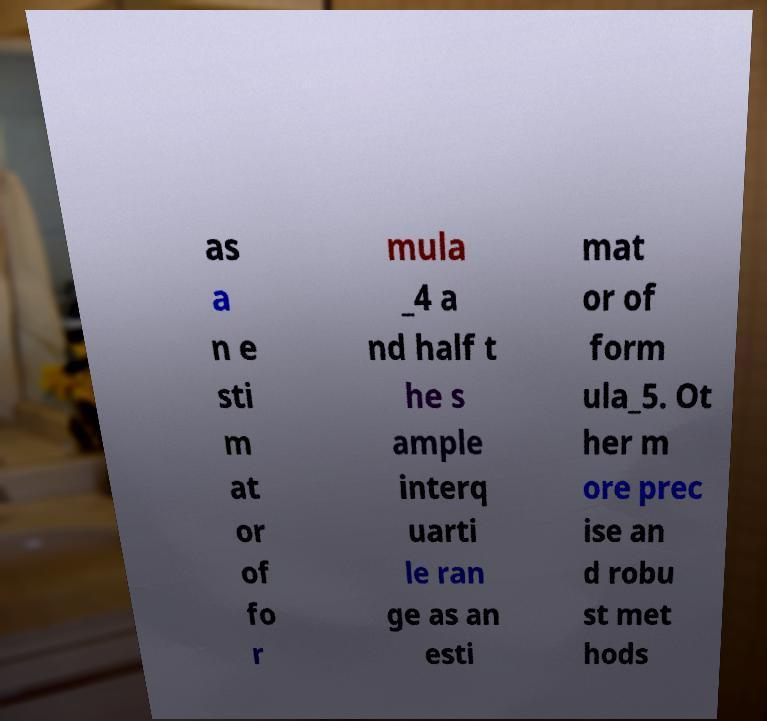There's text embedded in this image that I need extracted. Can you transcribe it verbatim? as a n e sti m at or of fo r mula _4 a nd half t he s ample interq uarti le ran ge as an esti mat or of form ula_5. Ot her m ore prec ise an d robu st met hods 